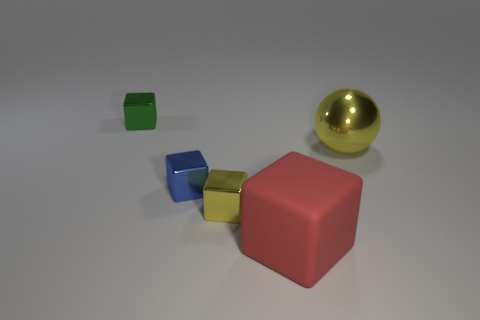What number of metal things have the same color as the sphere?
Keep it short and to the point. 1. What number of big matte blocks are there?
Offer a terse response. 1. How many red objects have the same material as the tiny green cube?
Offer a very short reply. 0. What is the size of the yellow object that is the same shape as the big red matte object?
Offer a terse response. Small. What is the material of the big red cube?
Keep it short and to the point. Rubber. The cube that is right of the yellow metallic object to the left of the large thing that is on the left side of the ball is made of what material?
Give a very brief answer. Rubber. Is there anything else that has the same shape as the large metallic object?
Your answer should be compact. No. Is the color of the block that is to the right of the tiny yellow metal object the same as the large thing to the right of the large red object?
Your response must be concise. No. Are there more big red matte cubes that are to the right of the red rubber cube than tiny blue cylinders?
Offer a terse response. No. What number of other objects are there of the same size as the yellow metal cube?
Give a very brief answer. 2. 